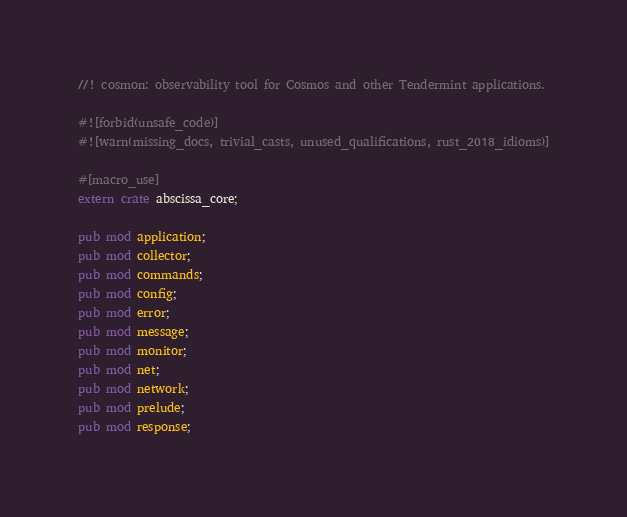Convert code to text. <code><loc_0><loc_0><loc_500><loc_500><_Rust_>//! cosmon: observability tool for Cosmos and other Tendermint applications.

#![forbid(unsafe_code)]
#![warn(missing_docs, trivial_casts, unused_qualifications, rust_2018_idioms)]

#[macro_use]
extern crate abscissa_core;

pub mod application;
pub mod collector;
pub mod commands;
pub mod config;
pub mod error;
pub mod message;
pub mod monitor;
pub mod net;
pub mod network;
pub mod prelude;
pub mod response;
</code> 